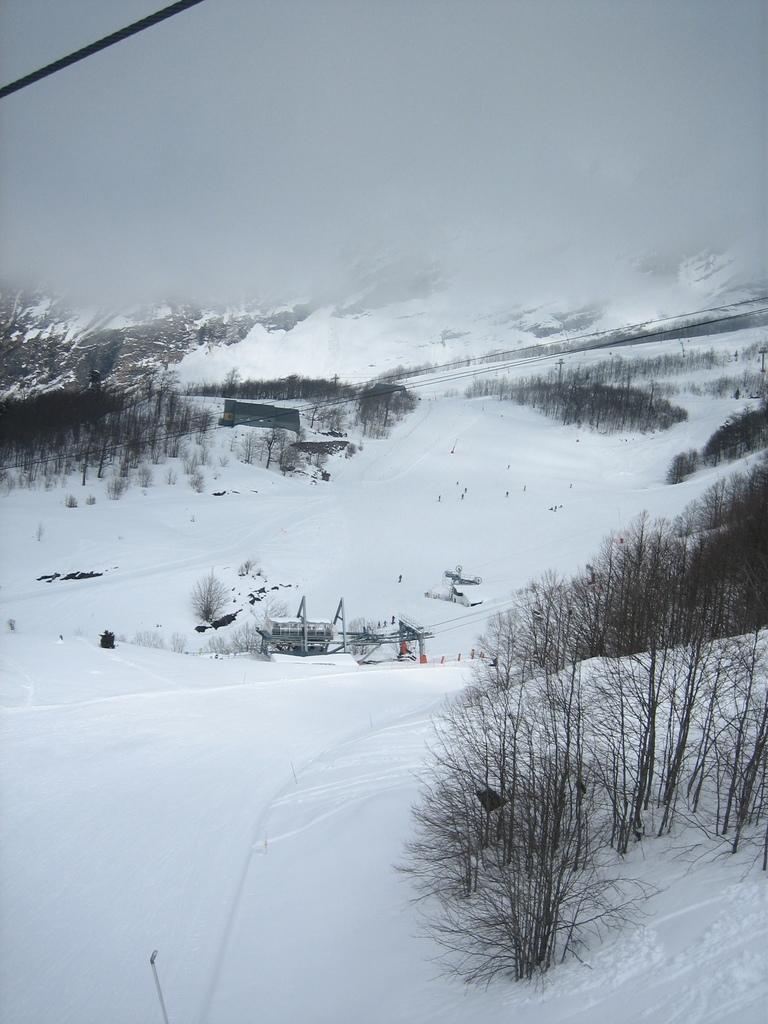How would you summarize this image in a sentence or two? This picture is clicked outside the city. In the center we can see the metal rods and some other objects are placed on the ground an the ground is covered with a lot of snow and we can see the trees, plants and hills. In the background we can see the sky and a cable. 